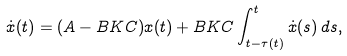<formula> <loc_0><loc_0><loc_500><loc_500>\dot { x } ( t ) = ( A - B K C ) x ( t ) + B K C \int _ { t - \tau ( t ) } ^ { t } \dot { x } ( s ) \, d s ,</formula> 